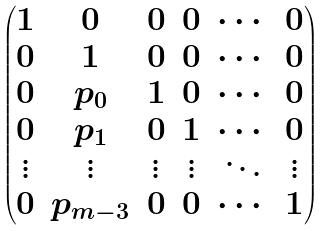Convert formula to latex. <formula><loc_0><loc_0><loc_500><loc_500>\begin{pmatrix} 1 & 0 & 0 & 0 & \cdots & 0 \\ 0 & 1 & 0 & 0 & \cdots & 0 \\ 0 & p _ { 0 } & 1 & 0 & \cdots & 0 \\ 0 & p _ { 1 } & 0 & 1 & \cdots & 0 \\ \vdots & \vdots & \vdots & \vdots & \ddots & \vdots \\ 0 & p _ { m - 3 } & 0 & 0 & \cdots & 1 \\ \end{pmatrix}</formula> 